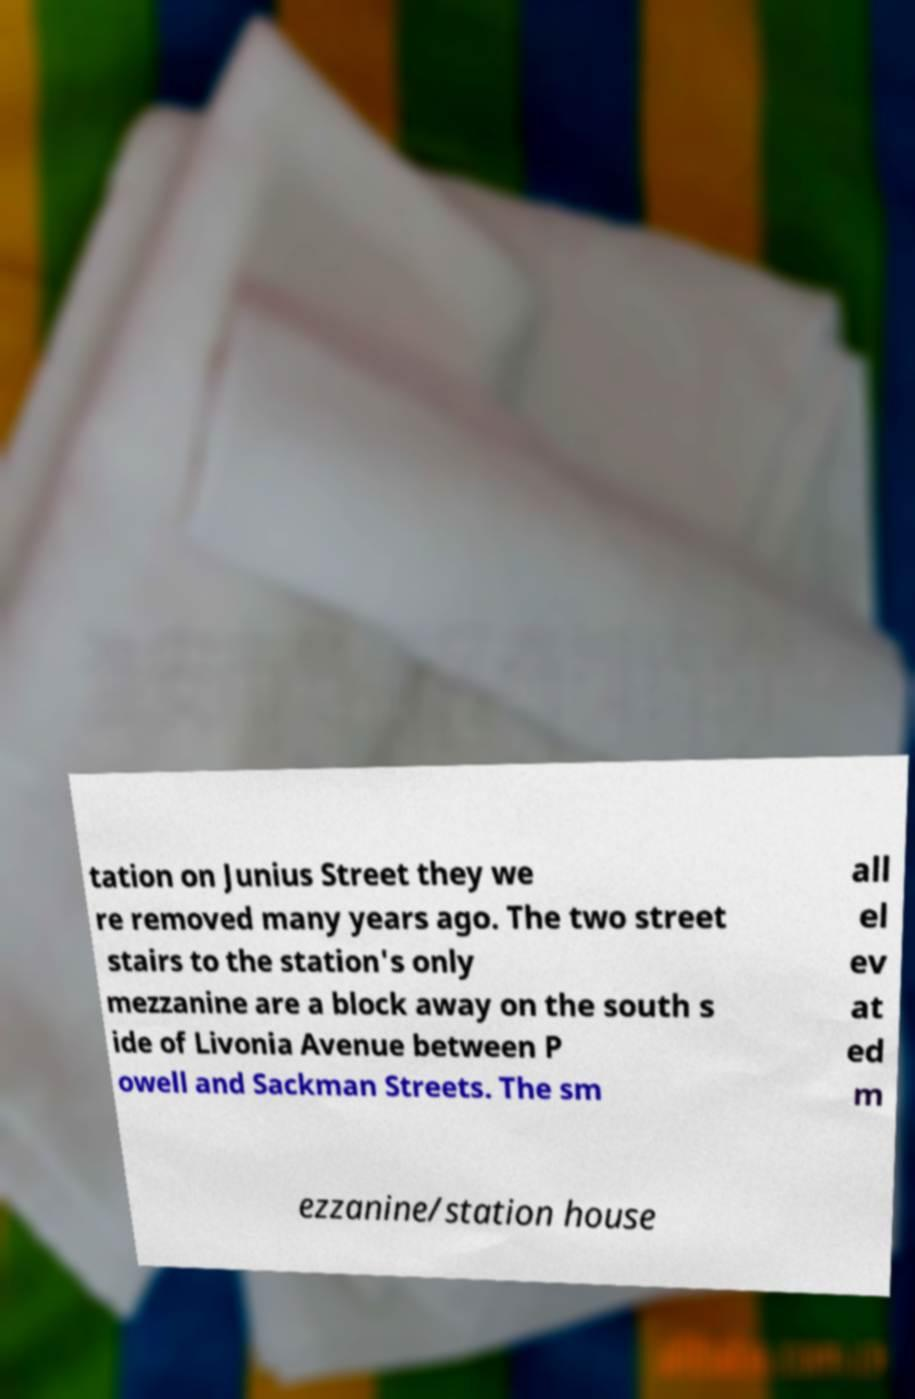For documentation purposes, I need the text within this image transcribed. Could you provide that? tation on Junius Street they we re removed many years ago. The two street stairs to the station's only mezzanine are a block away on the south s ide of Livonia Avenue between P owell and Sackman Streets. The sm all el ev at ed m ezzanine/station house 